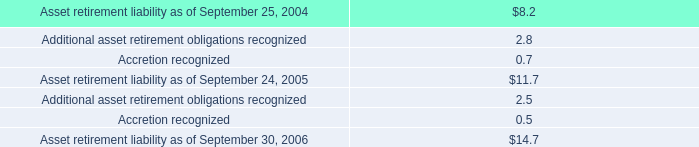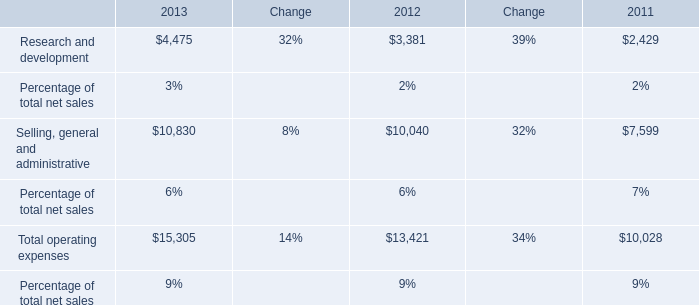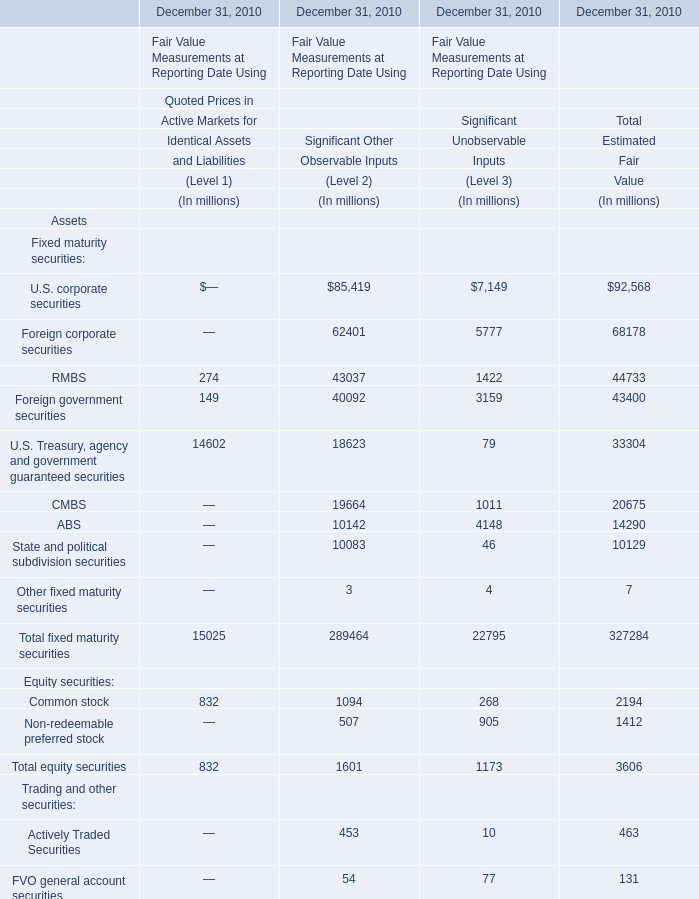What's the average of equity securities for total estimated fair value in 2010? 
Computations: ((2194 + 1412) / 2)
Answer: 1803.0. 